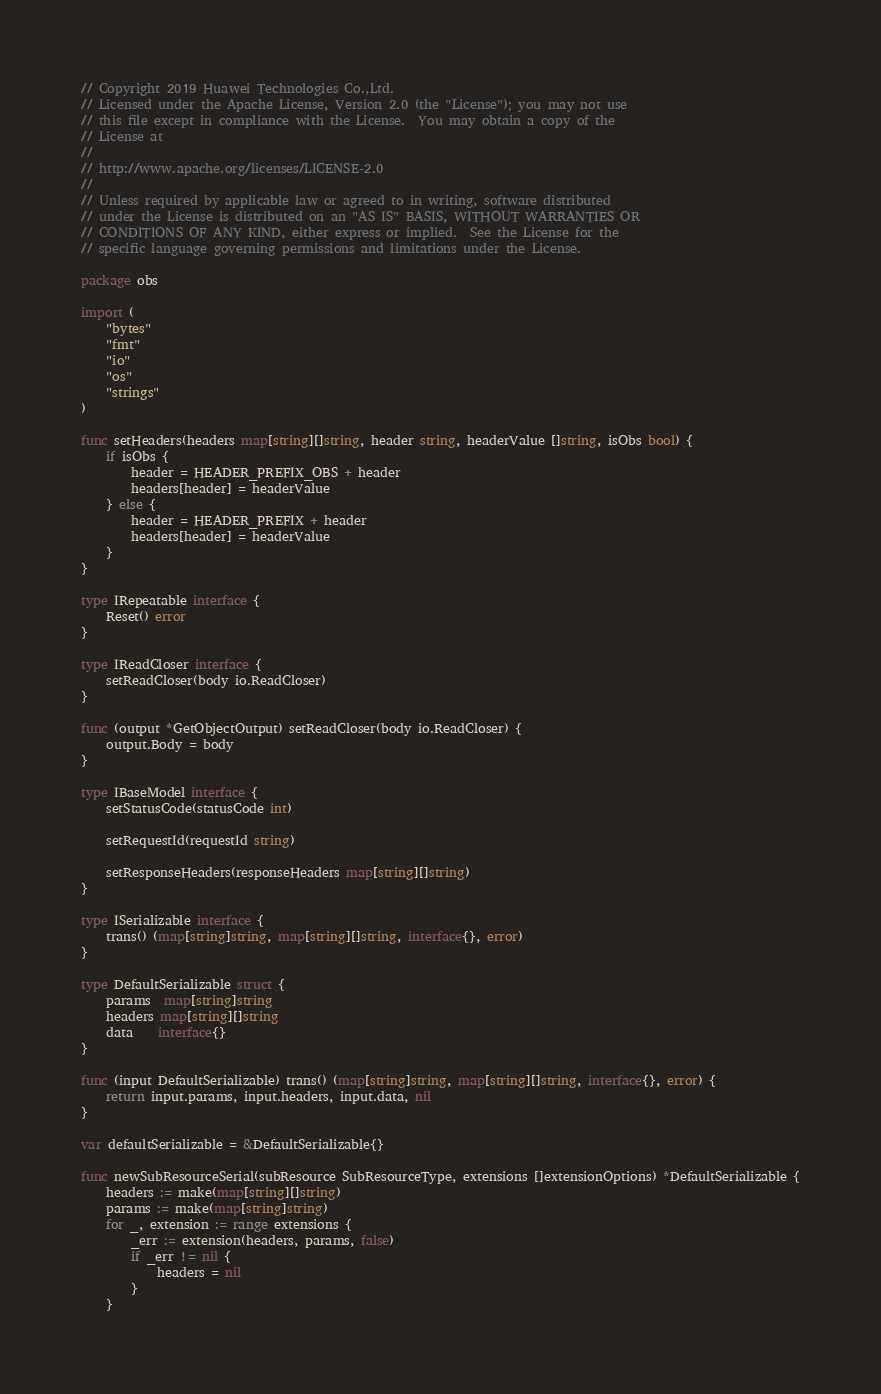Convert code to text. <code><loc_0><loc_0><loc_500><loc_500><_Go_>// Copyright 2019 Huawei Technologies Co.,Ltd.
// Licensed under the Apache License, Version 2.0 (the "License"); you may not use
// this file except in compliance with the License.  You may obtain a copy of the
// License at
//
// http://www.apache.org/licenses/LICENSE-2.0
//
// Unless required by applicable law or agreed to in writing, software distributed
// under the License is distributed on an "AS IS" BASIS, WITHOUT WARRANTIES OR
// CONDITIONS OF ANY KIND, either express or implied.  See the License for the
// specific language governing permissions and limitations under the License.

package obs

import (
	"bytes"
	"fmt"
	"io"
	"os"
	"strings"
)

func setHeaders(headers map[string][]string, header string, headerValue []string, isObs bool) {
	if isObs {
		header = HEADER_PREFIX_OBS + header
		headers[header] = headerValue
	} else {
		header = HEADER_PREFIX + header
		headers[header] = headerValue
	}
}

type IRepeatable interface {
	Reset() error
}

type IReadCloser interface {
	setReadCloser(body io.ReadCloser)
}

func (output *GetObjectOutput) setReadCloser(body io.ReadCloser) {
	output.Body = body
}

type IBaseModel interface {
	setStatusCode(statusCode int)

	setRequestId(requestId string)

	setResponseHeaders(responseHeaders map[string][]string)
}

type ISerializable interface {
	trans() (map[string]string, map[string][]string, interface{}, error)
}

type DefaultSerializable struct {
	params  map[string]string
	headers map[string][]string
	data    interface{}
}

func (input DefaultSerializable) trans() (map[string]string, map[string][]string, interface{}, error) {
	return input.params, input.headers, input.data, nil
}

var defaultSerializable = &DefaultSerializable{}

func newSubResourceSerial(subResource SubResourceType, extensions []extensionOptions) *DefaultSerializable {
	headers := make(map[string][]string)
	params := make(map[string]string)
	for _, extension := range extensions {
		_err := extension(headers, params, false)
		if _err != nil {
			headers = nil
		}
	}</code> 